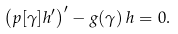<formula> <loc_0><loc_0><loc_500><loc_500>\left ( p [ \gamma ] h ^ { \prime } \right ) ^ { \prime } - g ( \gamma ) \, h = 0 .</formula> 